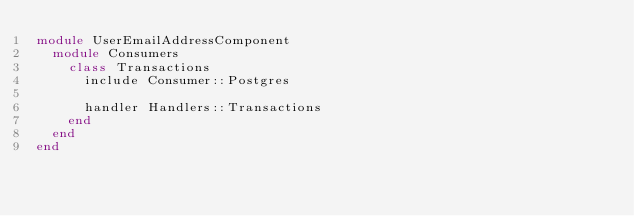<code> <loc_0><loc_0><loc_500><loc_500><_Ruby_>module UserEmailAddressComponent
  module Consumers
    class Transactions
      include Consumer::Postgres

      handler Handlers::Transactions
    end
  end
end
</code> 